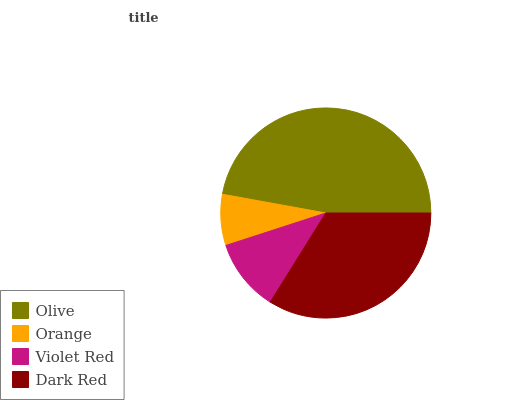Is Orange the minimum?
Answer yes or no. Yes. Is Olive the maximum?
Answer yes or no. Yes. Is Violet Red the minimum?
Answer yes or no. No. Is Violet Red the maximum?
Answer yes or no. No. Is Violet Red greater than Orange?
Answer yes or no. Yes. Is Orange less than Violet Red?
Answer yes or no. Yes. Is Orange greater than Violet Red?
Answer yes or no. No. Is Violet Red less than Orange?
Answer yes or no. No. Is Dark Red the high median?
Answer yes or no. Yes. Is Violet Red the low median?
Answer yes or no. Yes. Is Olive the high median?
Answer yes or no. No. Is Orange the low median?
Answer yes or no. No. 